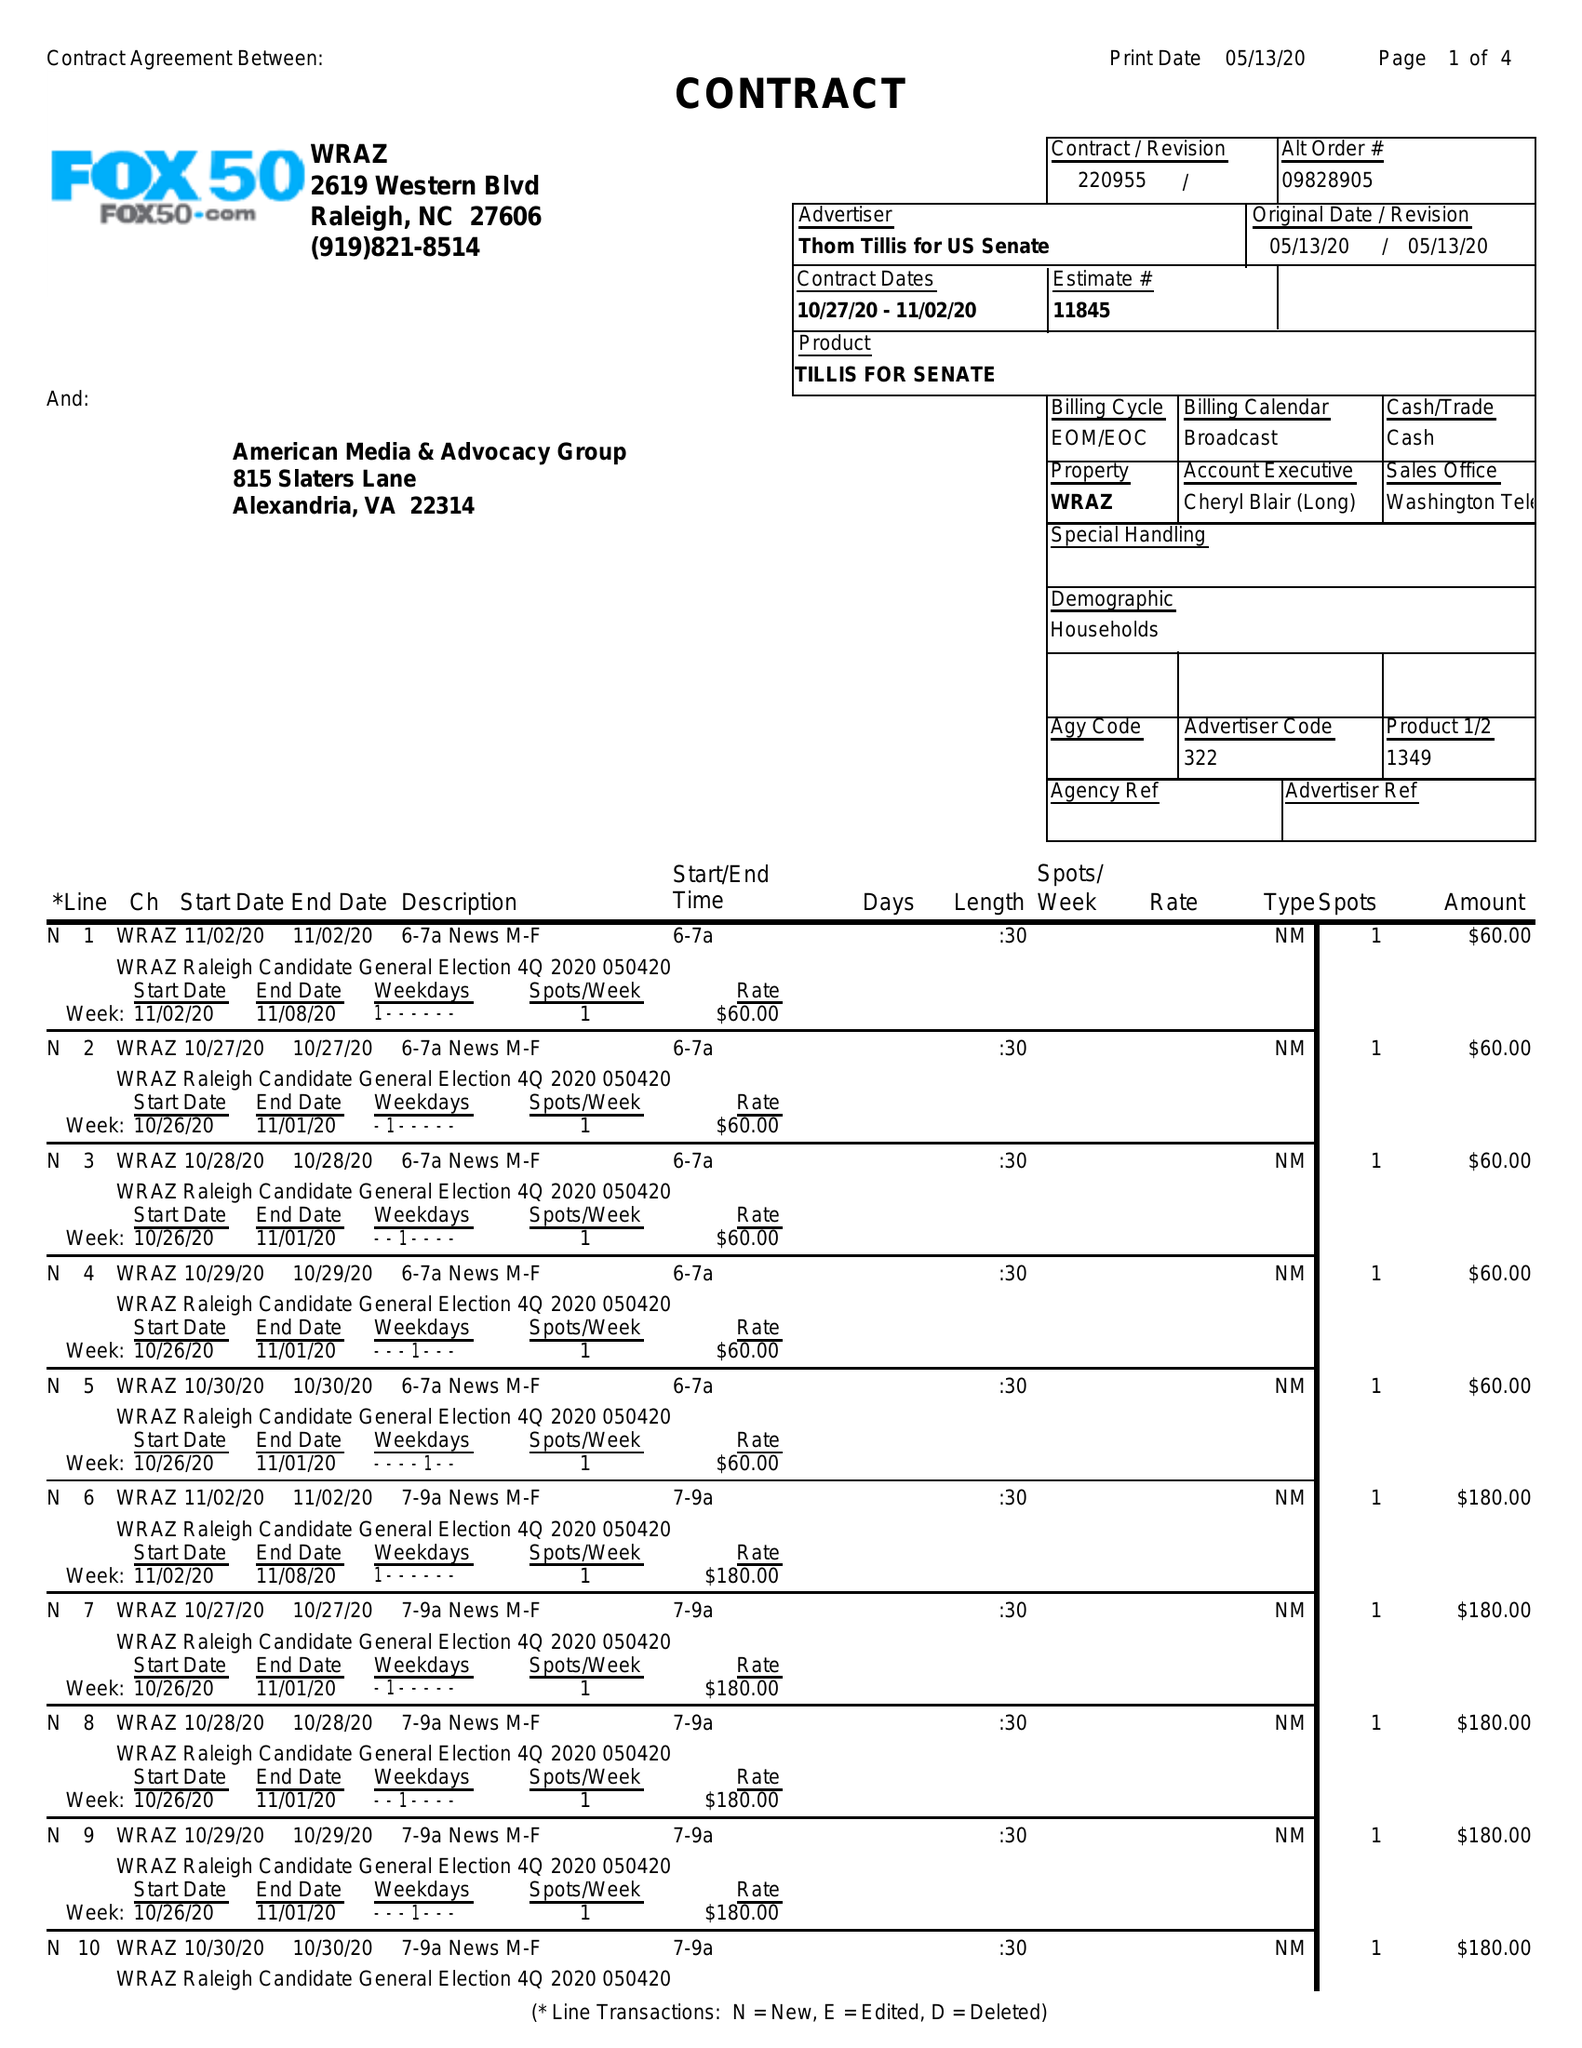What is the value for the flight_from?
Answer the question using a single word or phrase. 10/27/20 